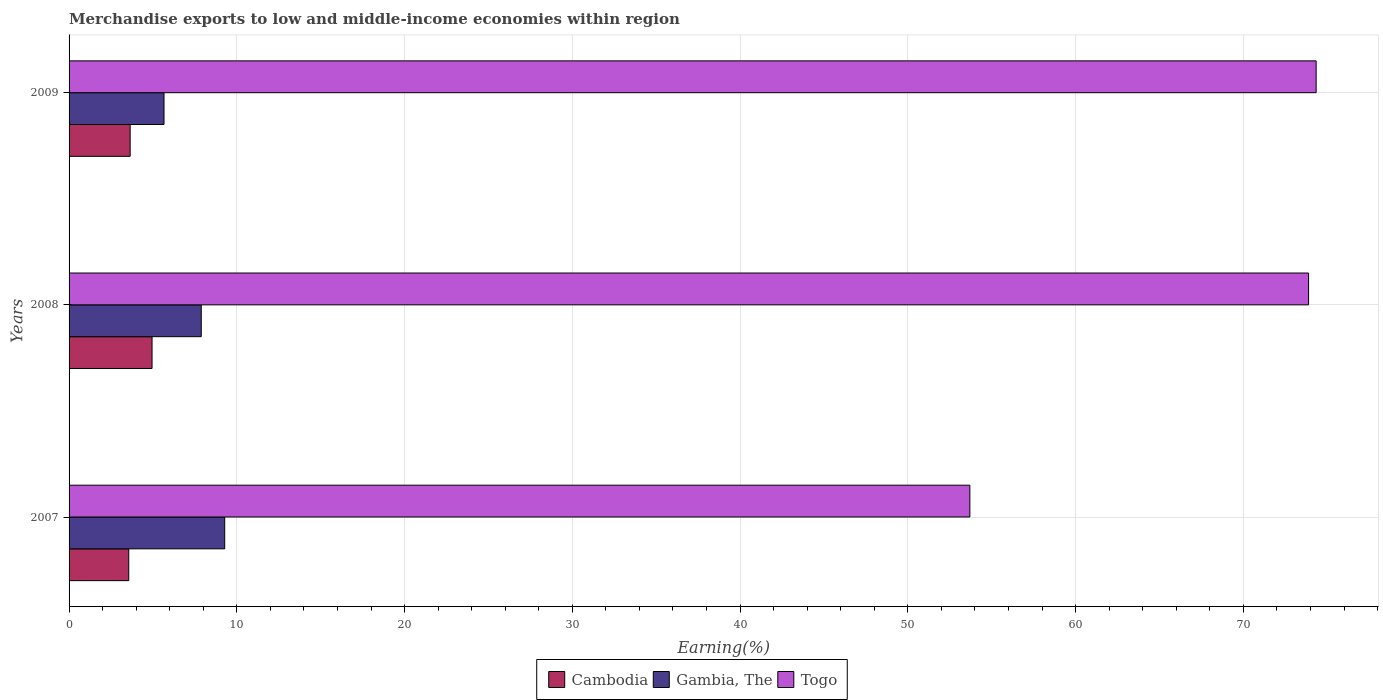How many bars are there on the 2nd tick from the top?
Your response must be concise. 3. What is the label of the 3rd group of bars from the top?
Provide a succinct answer. 2007. What is the percentage of amount earned from merchandise exports in Gambia, The in 2009?
Give a very brief answer. 5.66. Across all years, what is the maximum percentage of amount earned from merchandise exports in Gambia, The?
Give a very brief answer. 9.28. Across all years, what is the minimum percentage of amount earned from merchandise exports in Gambia, The?
Your answer should be compact. 5.66. In which year was the percentage of amount earned from merchandise exports in Gambia, The minimum?
Keep it short and to the point. 2009. What is the total percentage of amount earned from merchandise exports in Cambodia in the graph?
Your answer should be compact. 12.15. What is the difference between the percentage of amount earned from merchandise exports in Cambodia in 2007 and that in 2008?
Your answer should be compact. -1.39. What is the difference between the percentage of amount earned from merchandise exports in Gambia, The in 2008 and the percentage of amount earned from merchandise exports in Cambodia in 2007?
Offer a very short reply. 4.32. What is the average percentage of amount earned from merchandise exports in Gambia, The per year?
Offer a terse response. 7.61. In the year 2008, what is the difference between the percentage of amount earned from merchandise exports in Cambodia and percentage of amount earned from merchandise exports in Togo?
Keep it short and to the point. -68.94. In how many years, is the percentage of amount earned from merchandise exports in Cambodia greater than 28 %?
Ensure brevity in your answer.  0. What is the ratio of the percentage of amount earned from merchandise exports in Togo in 2008 to that in 2009?
Provide a succinct answer. 0.99. Is the difference between the percentage of amount earned from merchandise exports in Cambodia in 2007 and 2009 greater than the difference between the percentage of amount earned from merchandise exports in Togo in 2007 and 2009?
Your answer should be compact. Yes. What is the difference between the highest and the second highest percentage of amount earned from merchandise exports in Gambia, The?
Your answer should be compact. 1.4. What is the difference between the highest and the lowest percentage of amount earned from merchandise exports in Togo?
Make the answer very short. 20.64. Is the sum of the percentage of amount earned from merchandise exports in Gambia, The in 2007 and 2009 greater than the maximum percentage of amount earned from merchandise exports in Cambodia across all years?
Offer a terse response. Yes. What does the 2nd bar from the top in 2008 represents?
Ensure brevity in your answer.  Gambia, The. What does the 2nd bar from the bottom in 2007 represents?
Provide a short and direct response. Gambia, The. Is it the case that in every year, the sum of the percentage of amount earned from merchandise exports in Togo and percentage of amount earned from merchandise exports in Cambodia is greater than the percentage of amount earned from merchandise exports in Gambia, The?
Your response must be concise. Yes. How many bars are there?
Offer a terse response. 9. Are all the bars in the graph horizontal?
Your response must be concise. Yes. Are the values on the major ticks of X-axis written in scientific E-notation?
Ensure brevity in your answer.  No. Does the graph contain any zero values?
Offer a terse response. No. How are the legend labels stacked?
Your response must be concise. Horizontal. What is the title of the graph?
Provide a succinct answer. Merchandise exports to low and middle-income economies within region. What is the label or title of the X-axis?
Offer a terse response. Earning(%). What is the label or title of the Y-axis?
Your answer should be compact. Years. What is the Earning(%) of Cambodia in 2007?
Make the answer very short. 3.56. What is the Earning(%) of Gambia, The in 2007?
Give a very brief answer. 9.28. What is the Earning(%) of Togo in 2007?
Your answer should be very brief. 53.7. What is the Earning(%) in Cambodia in 2008?
Ensure brevity in your answer.  4.95. What is the Earning(%) in Gambia, The in 2008?
Your response must be concise. 7.88. What is the Earning(%) of Togo in 2008?
Give a very brief answer. 73.89. What is the Earning(%) in Cambodia in 2009?
Your response must be concise. 3.64. What is the Earning(%) of Gambia, The in 2009?
Make the answer very short. 5.66. What is the Earning(%) of Togo in 2009?
Provide a succinct answer. 74.34. Across all years, what is the maximum Earning(%) in Cambodia?
Your answer should be compact. 4.95. Across all years, what is the maximum Earning(%) of Gambia, The?
Offer a very short reply. 9.28. Across all years, what is the maximum Earning(%) of Togo?
Your response must be concise. 74.34. Across all years, what is the minimum Earning(%) in Cambodia?
Keep it short and to the point. 3.56. Across all years, what is the minimum Earning(%) in Gambia, The?
Keep it short and to the point. 5.66. Across all years, what is the minimum Earning(%) in Togo?
Provide a short and direct response. 53.7. What is the total Earning(%) of Cambodia in the graph?
Provide a succinct answer. 12.15. What is the total Earning(%) of Gambia, The in the graph?
Your response must be concise. 22.82. What is the total Earning(%) in Togo in the graph?
Ensure brevity in your answer.  201.92. What is the difference between the Earning(%) of Cambodia in 2007 and that in 2008?
Provide a short and direct response. -1.39. What is the difference between the Earning(%) of Gambia, The in 2007 and that in 2008?
Keep it short and to the point. 1.4. What is the difference between the Earning(%) in Togo in 2007 and that in 2008?
Your answer should be compact. -20.19. What is the difference between the Earning(%) in Cambodia in 2007 and that in 2009?
Offer a terse response. -0.08. What is the difference between the Earning(%) of Gambia, The in 2007 and that in 2009?
Provide a succinct answer. 3.62. What is the difference between the Earning(%) of Togo in 2007 and that in 2009?
Offer a terse response. -20.64. What is the difference between the Earning(%) in Cambodia in 2008 and that in 2009?
Provide a short and direct response. 1.3. What is the difference between the Earning(%) in Gambia, The in 2008 and that in 2009?
Provide a short and direct response. 2.22. What is the difference between the Earning(%) of Togo in 2008 and that in 2009?
Provide a short and direct response. -0.45. What is the difference between the Earning(%) in Cambodia in 2007 and the Earning(%) in Gambia, The in 2008?
Your answer should be compact. -4.32. What is the difference between the Earning(%) in Cambodia in 2007 and the Earning(%) in Togo in 2008?
Your answer should be very brief. -70.33. What is the difference between the Earning(%) of Gambia, The in 2007 and the Earning(%) of Togo in 2008?
Your answer should be very brief. -64.61. What is the difference between the Earning(%) in Cambodia in 2007 and the Earning(%) in Gambia, The in 2009?
Your response must be concise. -2.1. What is the difference between the Earning(%) in Cambodia in 2007 and the Earning(%) in Togo in 2009?
Offer a very short reply. -70.78. What is the difference between the Earning(%) of Gambia, The in 2007 and the Earning(%) of Togo in 2009?
Your answer should be very brief. -65.06. What is the difference between the Earning(%) of Cambodia in 2008 and the Earning(%) of Gambia, The in 2009?
Provide a succinct answer. -0.71. What is the difference between the Earning(%) in Cambodia in 2008 and the Earning(%) in Togo in 2009?
Your response must be concise. -69.39. What is the difference between the Earning(%) in Gambia, The in 2008 and the Earning(%) in Togo in 2009?
Provide a succinct answer. -66.46. What is the average Earning(%) of Cambodia per year?
Give a very brief answer. 4.05. What is the average Earning(%) in Gambia, The per year?
Keep it short and to the point. 7.61. What is the average Earning(%) of Togo per year?
Give a very brief answer. 67.31. In the year 2007, what is the difference between the Earning(%) in Cambodia and Earning(%) in Gambia, The?
Provide a short and direct response. -5.72. In the year 2007, what is the difference between the Earning(%) in Cambodia and Earning(%) in Togo?
Ensure brevity in your answer.  -50.14. In the year 2007, what is the difference between the Earning(%) of Gambia, The and Earning(%) of Togo?
Your answer should be very brief. -44.42. In the year 2008, what is the difference between the Earning(%) in Cambodia and Earning(%) in Gambia, The?
Keep it short and to the point. -2.93. In the year 2008, what is the difference between the Earning(%) of Cambodia and Earning(%) of Togo?
Offer a terse response. -68.94. In the year 2008, what is the difference between the Earning(%) in Gambia, The and Earning(%) in Togo?
Make the answer very short. -66.01. In the year 2009, what is the difference between the Earning(%) in Cambodia and Earning(%) in Gambia, The?
Offer a very short reply. -2.02. In the year 2009, what is the difference between the Earning(%) of Cambodia and Earning(%) of Togo?
Your answer should be very brief. -70.7. In the year 2009, what is the difference between the Earning(%) in Gambia, The and Earning(%) in Togo?
Offer a terse response. -68.68. What is the ratio of the Earning(%) of Cambodia in 2007 to that in 2008?
Provide a succinct answer. 0.72. What is the ratio of the Earning(%) of Gambia, The in 2007 to that in 2008?
Provide a succinct answer. 1.18. What is the ratio of the Earning(%) in Togo in 2007 to that in 2008?
Provide a succinct answer. 0.73. What is the ratio of the Earning(%) in Cambodia in 2007 to that in 2009?
Keep it short and to the point. 0.98. What is the ratio of the Earning(%) of Gambia, The in 2007 to that in 2009?
Your response must be concise. 1.64. What is the ratio of the Earning(%) of Togo in 2007 to that in 2009?
Your response must be concise. 0.72. What is the ratio of the Earning(%) in Cambodia in 2008 to that in 2009?
Offer a very short reply. 1.36. What is the ratio of the Earning(%) in Gambia, The in 2008 to that in 2009?
Offer a very short reply. 1.39. What is the difference between the highest and the second highest Earning(%) of Cambodia?
Keep it short and to the point. 1.3. What is the difference between the highest and the second highest Earning(%) of Gambia, The?
Provide a succinct answer. 1.4. What is the difference between the highest and the second highest Earning(%) of Togo?
Provide a succinct answer. 0.45. What is the difference between the highest and the lowest Earning(%) in Cambodia?
Offer a terse response. 1.39. What is the difference between the highest and the lowest Earning(%) in Gambia, The?
Give a very brief answer. 3.62. What is the difference between the highest and the lowest Earning(%) of Togo?
Offer a terse response. 20.64. 